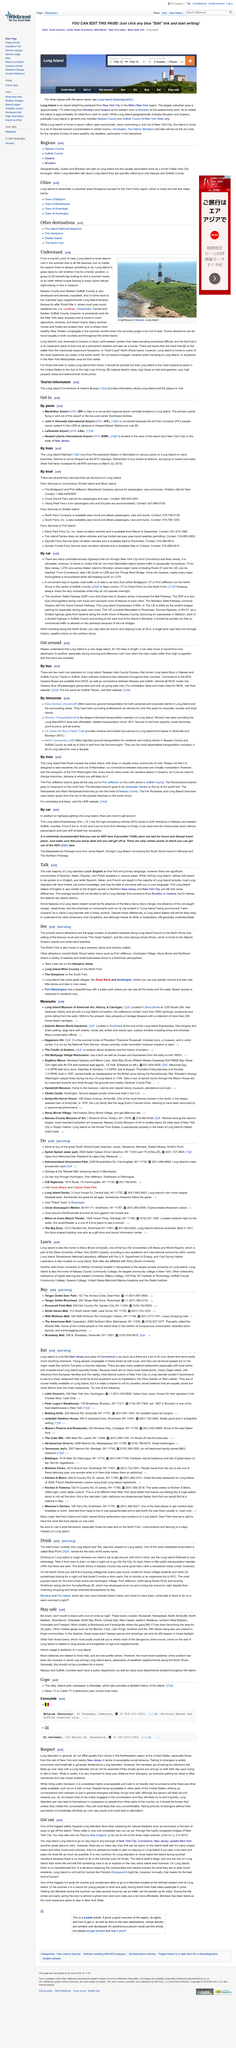Mention a couple of crucial points in this snapshot. The more rural areas of Long Island can be found in Central and Eastern Suffolk County, representing the ideal location for those seeking a peaceful and secluded lifestyle away from the hustle and bustle of urban areas. It is recommended to visit Long Island during the summer months as it offers a variety of beaches and other tourist attractions. Some counties on Long Island, including Nassau County and parts of Suffolk County, have high populations and are thus densely populated. 